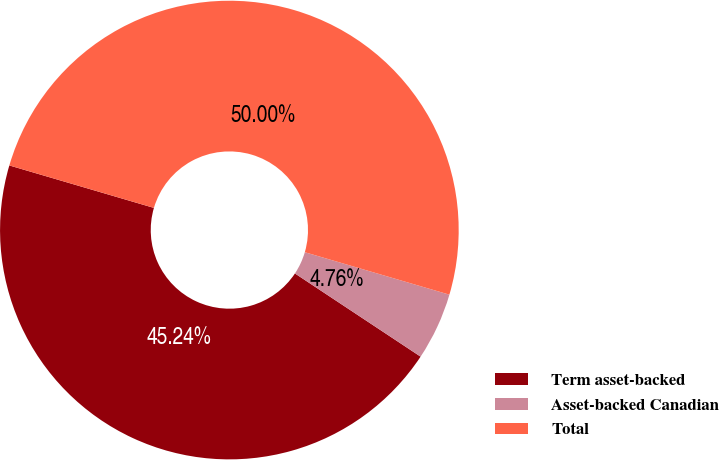<chart> <loc_0><loc_0><loc_500><loc_500><pie_chart><fcel>Term asset-backed<fcel>Asset-backed Canadian<fcel>Total<nl><fcel>45.24%<fcel>4.76%<fcel>50.0%<nl></chart> 